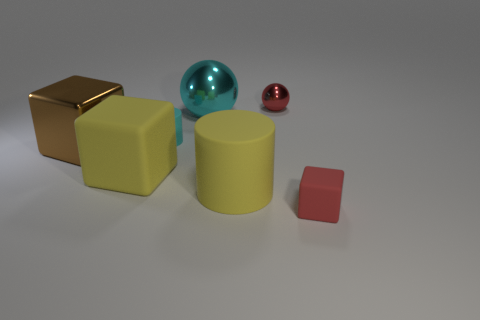Are there any large metal cubes in front of the large yellow matte object that is behind the cylinder that is in front of the small cyan object?
Provide a succinct answer. No. What is the color of the other cylinder that is made of the same material as the big cylinder?
Keep it short and to the point. Cyan. How many yellow cylinders are the same material as the cyan cylinder?
Offer a terse response. 1. Is the red sphere made of the same material as the brown cube behind the big matte cylinder?
Make the answer very short. Yes. What number of things are either rubber cubes behind the small red matte thing or tiny matte cylinders?
Make the answer very short. 2. How big is the yellow object that is right of the matte cylinder on the left side of the rubber cylinder in front of the brown shiny object?
Provide a short and direct response. Large. There is a object that is the same color as the small cylinder; what material is it?
Offer a terse response. Metal. There is a rubber cube that is to the left of the matte thing to the right of the tiny ball; what is its size?
Offer a very short reply. Large. How many big things are yellow cylinders or balls?
Ensure brevity in your answer.  2. Are there fewer red blocks than large cyan rubber blocks?
Your answer should be very brief. No. 